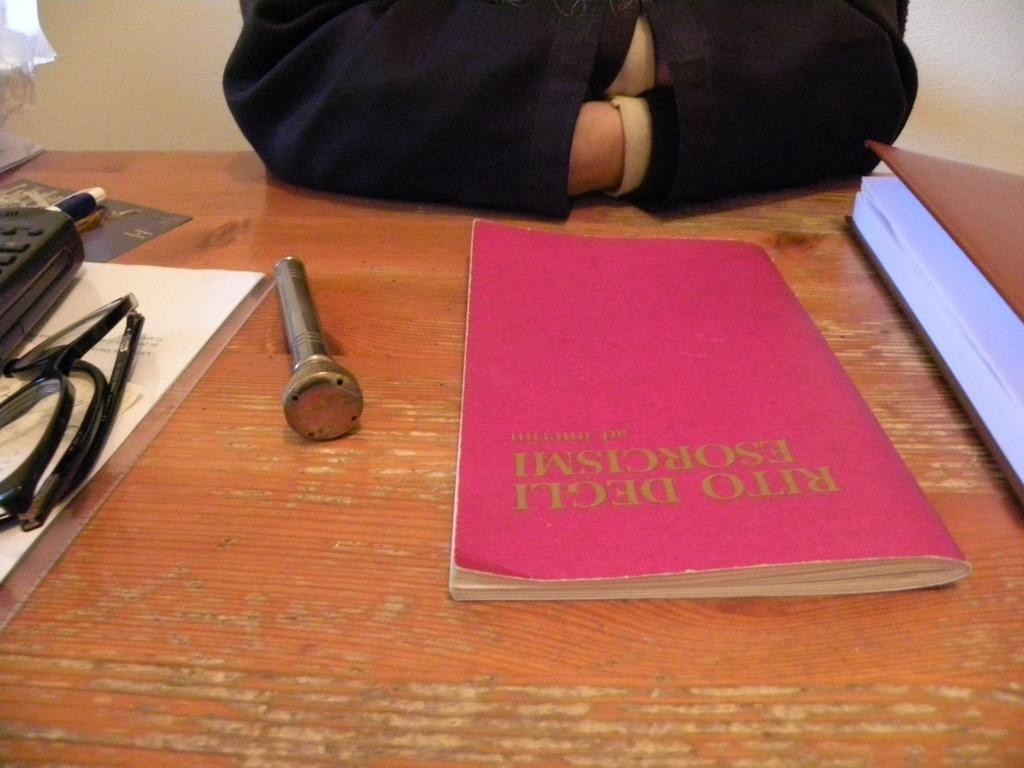<image>
Relay a brief, clear account of the picture shown. A copy of Rito Degli Esorcismi sits on the table in front of a person. 